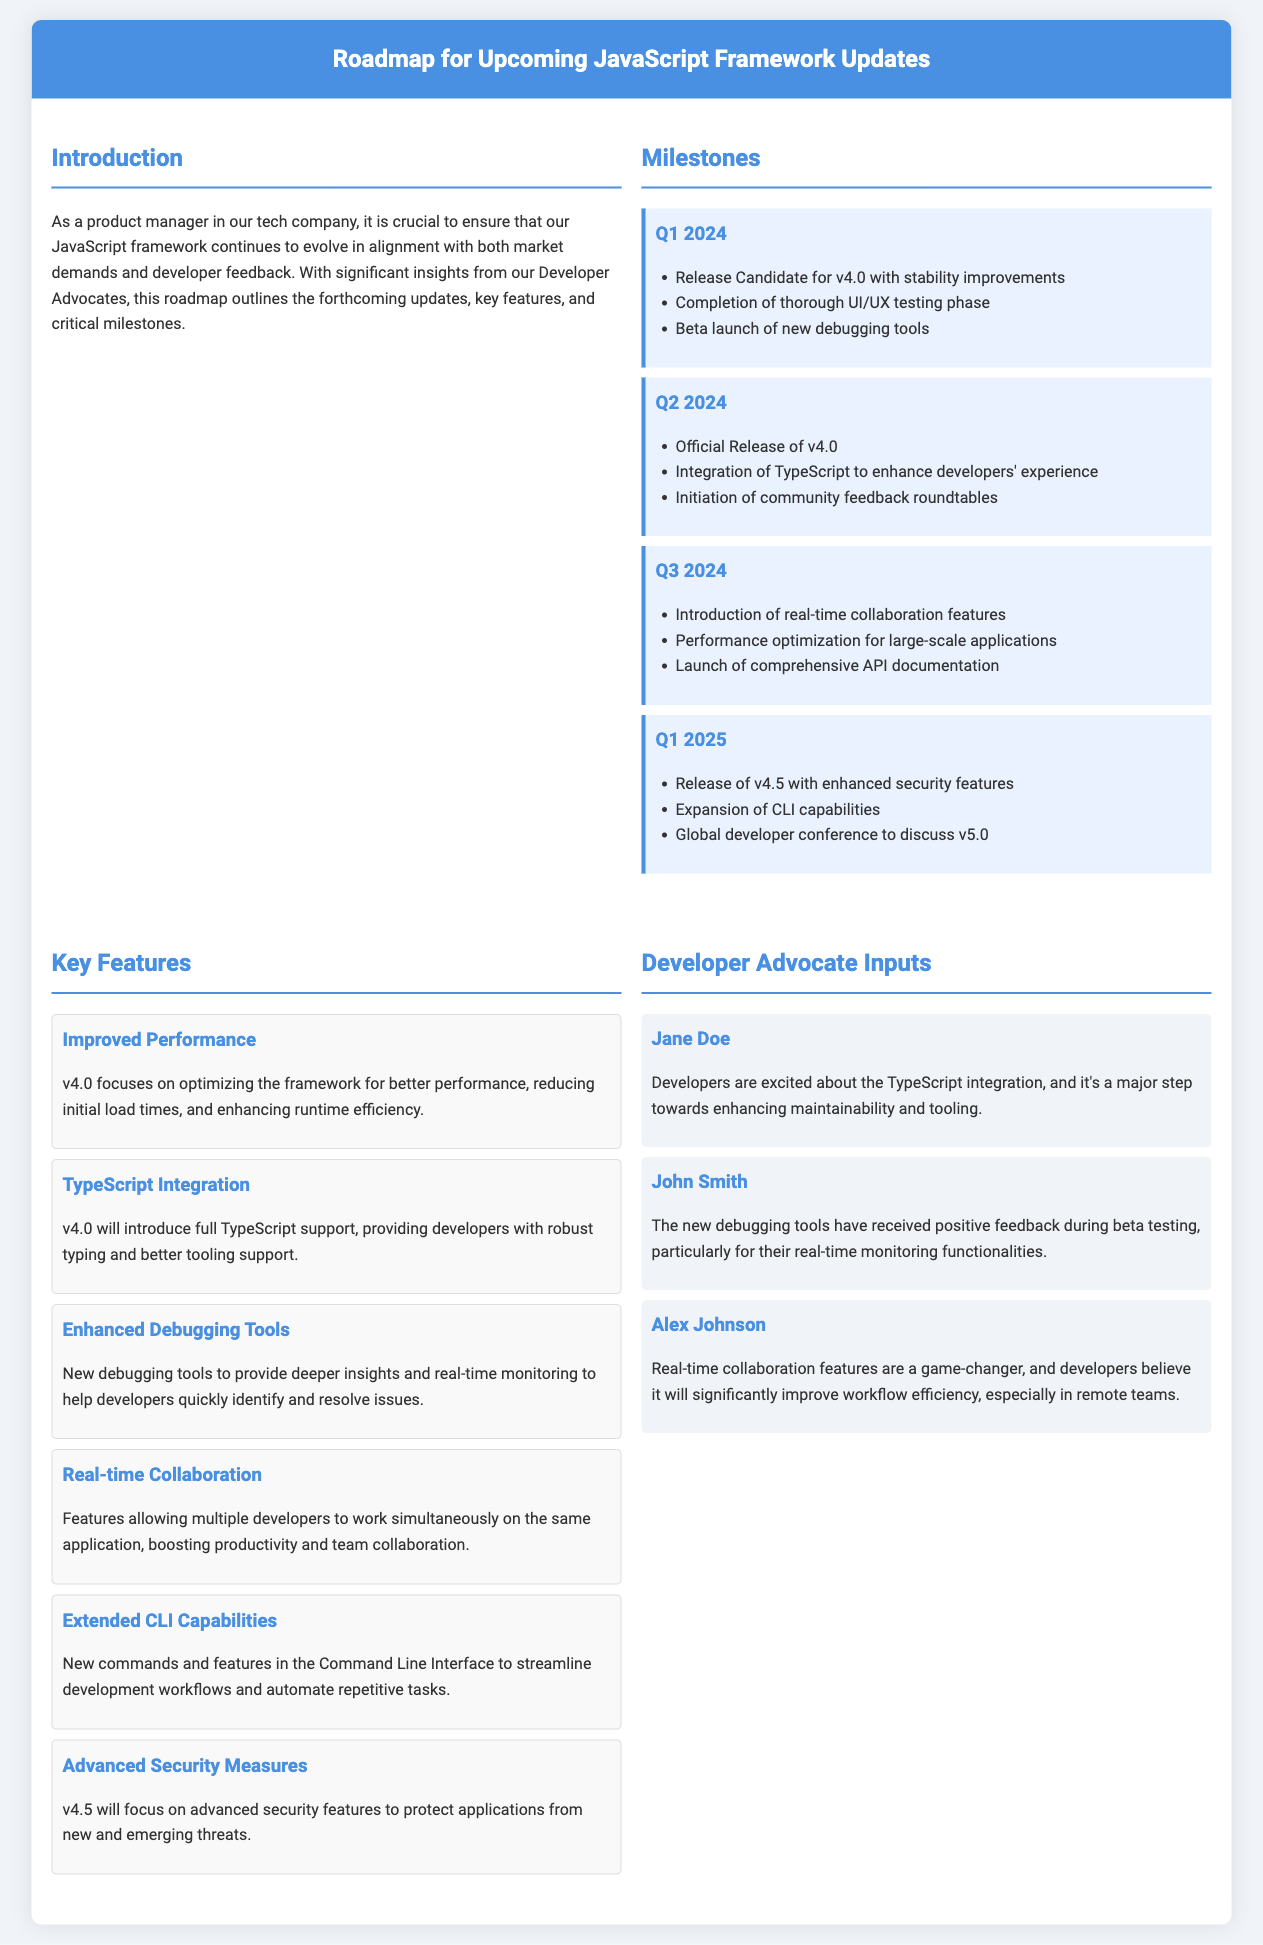What is the official release date for v4.0? The official release of v4.0 is scheduled for Q2 2024.
Answer: Q2 2024 Which feature focuses on optimizing framework performance? The improved performance feature in v4.0 aims to reduce initial load times and enhance runtime efficiency.
Answer: Improved Performance Who provided feedback on the TypeScript integration? Jane Doe is the Developer Advocate who commented on the excitement surrounding TypeScript integration.
Answer: Jane Doe What milestone occurs in Q1 2025? In Q1 2025, the release of v4.5 with enhanced security features is planned.
Answer: Release of v4.5 How many key features are highlighted in the document? There are six key features highlighted in the document.
Answer: Six Which milestone includes the community feedback roundtables? The community feedback roundtables are initiated in Q2 2024.
Answer: Q2 2024 Who believes that real-time collaboration features will improve workflow efficiency? Alex Johnson expresses that the real-time collaboration features will significantly improve workflow efficiency.
Answer: Alex Johnson What enhances the developers' experience according to the 2024 roadmap? TypeScript integration is aimed at enhancing developers' experience.
Answer: TypeScript Integration What does the new debugging tools feature provide? The new debugging tools provide deeper insights and real-time monitoring for developers.
Answer: Deeper insights and real-time monitoring 